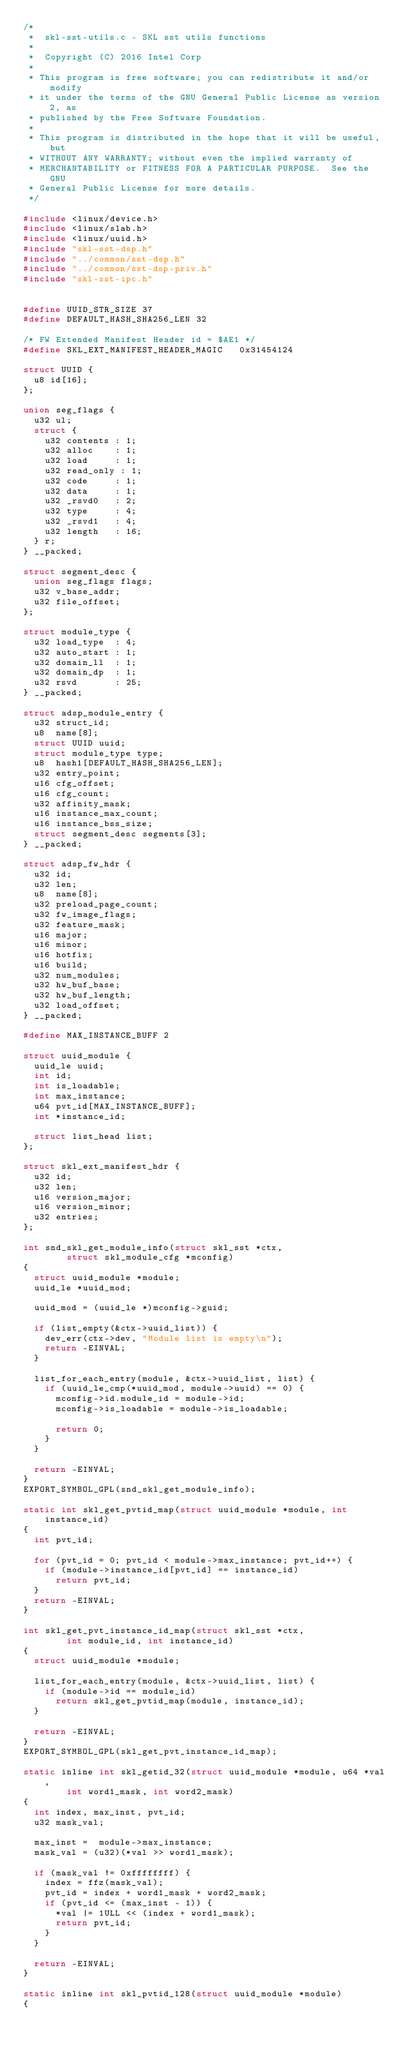<code> <loc_0><loc_0><loc_500><loc_500><_C_>/*
 *  skl-sst-utils.c - SKL sst utils functions
 *
 *  Copyright (C) 2016 Intel Corp
 *
 * This program is free software; you can redistribute it and/or modify
 * it under the terms of the GNU General Public License as version 2, as
 * published by the Free Software Foundation.
 *
 * This program is distributed in the hope that it will be useful, but
 * WITHOUT ANY WARRANTY; without even the implied warranty of
 * MERCHANTABILITY or FITNESS FOR A PARTICULAR PURPOSE.  See the GNU
 * General Public License for more details.
 */

#include <linux/device.h>
#include <linux/slab.h>
#include <linux/uuid.h>
#include "skl-sst-dsp.h"
#include "../common/sst-dsp.h"
#include "../common/sst-dsp-priv.h"
#include "skl-sst-ipc.h"


#define UUID_STR_SIZE 37
#define DEFAULT_HASH_SHA256_LEN 32

/* FW Extended Manifest Header id = $AE1 */
#define SKL_EXT_MANIFEST_HEADER_MAGIC   0x31454124

struct UUID {
	u8 id[16];
};

union seg_flags {
	u32 ul;
	struct {
		u32 contents : 1;
		u32 alloc    : 1;
		u32 load     : 1;
		u32 read_only : 1;
		u32 code     : 1;
		u32 data     : 1;
		u32 _rsvd0   : 2;
		u32 type     : 4;
		u32 _rsvd1   : 4;
		u32 length   : 16;
	} r;
} __packed;

struct segment_desc {
	union seg_flags flags;
	u32 v_base_addr;
	u32 file_offset;
};

struct module_type {
	u32 load_type  : 4;
	u32 auto_start : 1;
	u32 domain_ll  : 1;
	u32 domain_dp  : 1;
	u32 rsvd       : 25;
} __packed;

struct adsp_module_entry {
	u32 struct_id;
	u8  name[8];
	struct UUID uuid;
	struct module_type type;
	u8  hash1[DEFAULT_HASH_SHA256_LEN];
	u32 entry_point;
	u16 cfg_offset;
	u16 cfg_count;
	u32 affinity_mask;
	u16 instance_max_count;
	u16 instance_bss_size;
	struct segment_desc segments[3];
} __packed;

struct adsp_fw_hdr {
	u32 id;
	u32 len;
	u8  name[8];
	u32 preload_page_count;
	u32 fw_image_flags;
	u32 feature_mask;
	u16 major;
	u16 minor;
	u16 hotfix;
	u16 build;
	u32 num_modules;
	u32 hw_buf_base;
	u32 hw_buf_length;
	u32 load_offset;
} __packed;

#define MAX_INSTANCE_BUFF 2

struct uuid_module {
	uuid_le uuid;
	int id;
	int is_loadable;
	int max_instance;
	u64 pvt_id[MAX_INSTANCE_BUFF];
	int *instance_id;

	struct list_head list;
};

struct skl_ext_manifest_hdr {
	u32 id;
	u32 len;
	u16 version_major;
	u16 version_minor;
	u32 entries;
};

int snd_skl_get_module_info(struct skl_sst *ctx,
				struct skl_module_cfg *mconfig)
{
	struct uuid_module *module;
	uuid_le *uuid_mod;

	uuid_mod = (uuid_le *)mconfig->guid;

	if (list_empty(&ctx->uuid_list)) {
		dev_err(ctx->dev, "Module list is empty\n");
		return -EINVAL;
	}

	list_for_each_entry(module, &ctx->uuid_list, list) {
		if (uuid_le_cmp(*uuid_mod, module->uuid) == 0) {
			mconfig->id.module_id = module->id;
			mconfig->is_loadable = module->is_loadable;

			return 0;
		}
	}

	return -EINVAL;
}
EXPORT_SYMBOL_GPL(snd_skl_get_module_info);

static int skl_get_pvtid_map(struct uuid_module *module, int instance_id)
{
	int pvt_id;

	for (pvt_id = 0; pvt_id < module->max_instance; pvt_id++) {
		if (module->instance_id[pvt_id] == instance_id)
			return pvt_id;
	}
	return -EINVAL;
}

int skl_get_pvt_instance_id_map(struct skl_sst *ctx,
				int module_id, int instance_id)
{
	struct uuid_module *module;

	list_for_each_entry(module, &ctx->uuid_list, list) {
		if (module->id == module_id)
			return skl_get_pvtid_map(module, instance_id);
	}

	return -EINVAL;
}
EXPORT_SYMBOL_GPL(skl_get_pvt_instance_id_map);

static inline int skl_getid_32(struct uuid_module *module, u64 *val,
				int word1_mask, int word2_mask)
{
	int index, max_inst, pvt_id;
	u32 mask_val;

	max_inst =  module->max_instance;
	mask_val = (u32)(*val >> word1_mask);

	if (mask_val != 0xffffffff) {
		index = ffz(mask_val);
		pvt_id = index + word1_mask + word2_mask;
		if (pvt_id <= (max_inst - 1)) {
			*val |= 1ULL << (index + word1_mask);
			return pvt_id;
		}
	}

	return -EINVAL;
}

static inline int skl_pvtid_128(struct uuid_module *module)
{</code> 